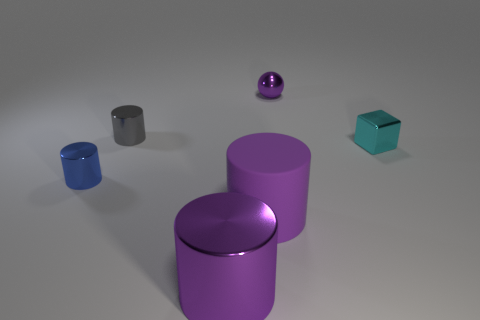There is a gray thing that is made of the same material as the blue object; what size is it?
Your answer should be very brief. Small. How many matte things are the same color as the big metallic thing?
Ensure brevity in your answer.  1. Does the metal cylinder that is behind the small cyan shiny block have the same color as the metal sphere?
Provide a short and direct response. No. Is the number of small things that are behind the gray thing the same as the number of small cyan blocks behind the tiny blue thing?
Ensure brevity in your answer.  Yes. Are there any other things that have the same material as the block?
Your response must be concise. Yes. The cylinder that is behind the blue cylinder is what color?
Provide a short and direct response. Gray. Are there an equal number of big purple shiny objects behind the purple shiny ball and blocks?
Your response must be concise. No. What number of other objects are the same shape as the tiny purple object?
Your answer should be very brief. 0. There is a large purple rubber cylinder; how many blue cylinders are behind it?
Your response must be concise. 1. What is the size of the shiny object that is both behind the big purple matte cylinder and in front of the small block?
Your response must be concise. Small. 